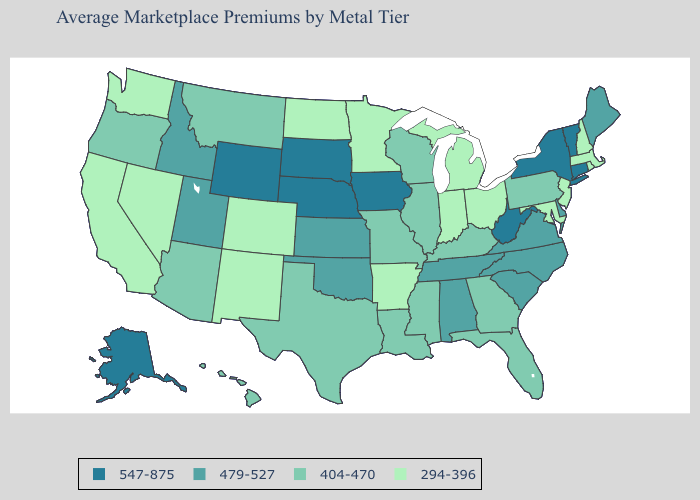Does the map have missing data?
Be succinct. No. What is the highest value in states that border Montana?
Concise answer only. 547-875. What is the lowest value in the MidWest?
Keep it brief. 294-396. Does the map have missing data?
Quick response, please. No. What is the highest value in states that border Virginia?
Be succinct. 547-875. Is the legend a continuous bar?
Keep it brief. No. Among the states that border Tennessee , which have the lowest value?
Keep it brief. Arkansas. What is the value of North Dakota?
Answer briefly. 294-396. Which states have the lowest value in the MidWest?
Concise answer only. Indiana, Michigan, Minnesota, North Dakota, Ohio. Does Vermont have the lowest value in the USA?
Quick response, please. No. Which states have the lowest value in the USA?
Keep it brief. Arkansas, California, Colorado, Indiana, Maryland, Massachusetts, Michigan, Minnesota, Nevada, New Hampshire, New Jersey, New Mexico, North Dakota, Ohio, Rhode Island, Washington. Which states have the lowest value in the West?
Concise answer only. California, Colorado, Nevada, New Mexico, Washington. What is the value of Vermont?
Keep it brief. 547-875. Does the map have missing data?
Write a very short answer. No. Which states have the lowest value in the West?
Concise answer only. California, Colorado, Nevada, New Mexico, Washington. 